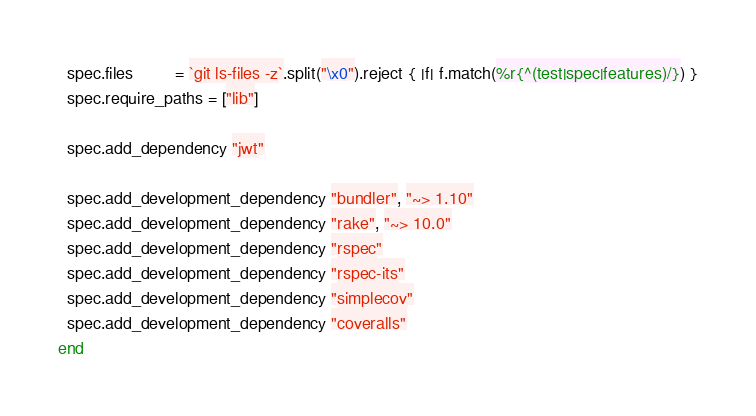Convert code to text. <code><loc_0><loc_0><loc_500><loc_500><_Ruby_>  spec.files         = `git ls-files -z`.split("\x0").reject { |f| f.match(%r{^(test|spec|features)/}) }
  spec.require_paths = ["lib"]

  spec.add_dependency "jwt"

  spec.add_development_dependency "bundler", "~> 1.10"
  spec.add_development_dependency "rake", "~> 10.0"
  spec.add_development_dependency "rspec"
  spec.add_development_dependency "rspec-its"
  spec.add_development_dependency "simplecov"
  spec.add_development_dependency "coveralls"
end
</code> 